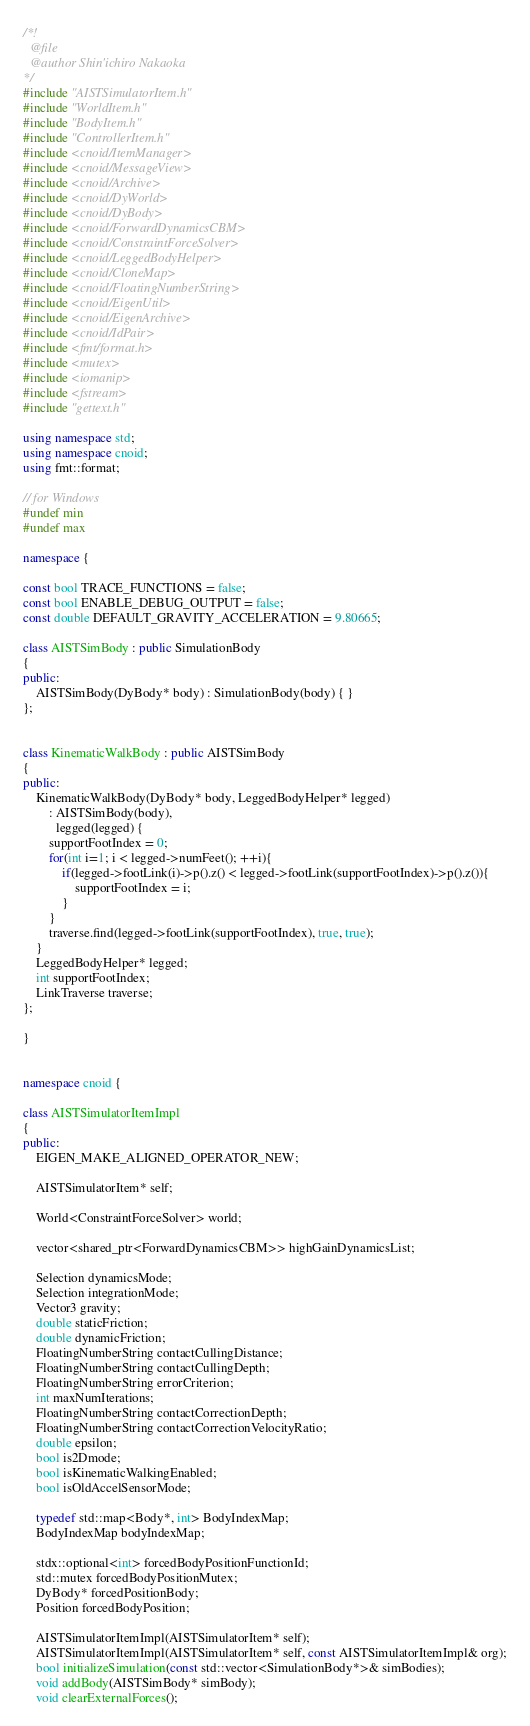Convert code to text. <code><loc_0><loc_0><loc_500><loc_500><_C++_>/*!
  @file
  @author Shin'ichiro Nakaoka
*/
#include "AISTSimulatorItem.h"
#include "WorldItem.h"
#include "BodyItem.h"
#include "ControllerItem.h"
#include <cnoid/ItemManager>
#include <cnoid/MessageView>
#include <cnoid/Archive>
#include <cnoid/DyWorld>
#include <cnoid/DyBody>
#include <cnoid/ForwardDynamicsCBM>
#include <cnoid/ConstraintForceSolver>
#include <cnoid/LeggedBodyHelper>
#include <cnoid/CloneMap>
#include <cnoid/FloatingNumberString>
#include <cnoid/EigenUtil>
#include <cnoid/EigenArchive>
#include <cnoid/IdPair>
#include <fmt/format.h>
#include <mutex>
#include <iomanip>
#include <fstream>
#include "gettext.h"

using namespace std;
using namespace cnoid;
using fmt::format;

// for Windows
#undef min
#undef max

namespace {

const bool TRACE_FUNCTIONS = false;
const bool ENABLE_DEBUG_OUTPUT = false;
const double DEFAULT_GRAVITY_ACCELERATION = 9.80665;

class AISTSimBody : public SimulationBody
{
public:
    AISTSimBody(DyBody* body) : SimulationBody(body) { }
};
    

class KinematicWalkBody : public AISTSimBody
{
public:
    KinematicWalkBody(DyBody* body, LeggedBodyHelper* legged)
        : AISTSimBody(body),
          legged(legged) {
        supportFootIndex = 0;
        for(int i=1; i < legged->numFeet(); ++i){
            if(legged->footLink(i)->p().z() < legged->footLink(supportFootIndex)->p().z()){
                supportFootIndex = i;
            }
        }
        traverse.find(legged->footLink(supportFootIndex), true, true);
    }
    LeggedBodyHelper* legged;
    int supportFootIndex;
    LinkTraverse traverse;
};

}


namespace cnoid {
  
class AISTSimulatorItemImpl
{
public:
    EIGEN_MAKE_ALIGNED_OPERATOR_NEW;

    AISTSimulatorItem* self;

    World<ConstraintForceSolver> world;

    vector<shared_ptr<ForwardDynamicsCBM>> highGainDynamicsList;
        
    Selection dynamicsMode;
    Selection integrationMode;
    Vector3 gravity;
    double staticFriction;
    double dynamicFriction;
    FloatingNumberString contactCullingDistance;
    FloatingNumberString contactCullingDepth;
    FloatingNumberString errorCriterion;
    int maxNumIterations;
    FloatingNumberString contactCorrectionDepth;
    FloatingNumberString contactCorrectionVelocityRatio;
    double epsilon;
    bool is2Dmode;
    bool isKinematicWalkingEnabled;
    bool isOldAccelSensorMode;

    typedef std::map<Body*, int> BodyIndexMap;
    BodyIndexMap bodyIndexMap;

    stdx::optional<int> forcedBodyPositionFunctionId;
    std::mutex forcedBodyPositionMutex;
    DyBody* forcedPositionBody;
    Position forcedBodyPosition;

    AISTSimulatorItemImpl(AISTSimulatorItem* self);
    AISTSimulatorItemImpl(AISTSimulatorItem* self, const AISTSimulatorItemImpl& org);
    bool initializeSimulation(const std::vector<SimulationBody*>& simBodies);
    void addBody(AISTSimBody* simBody);
    void clearExternalForces();</code> 